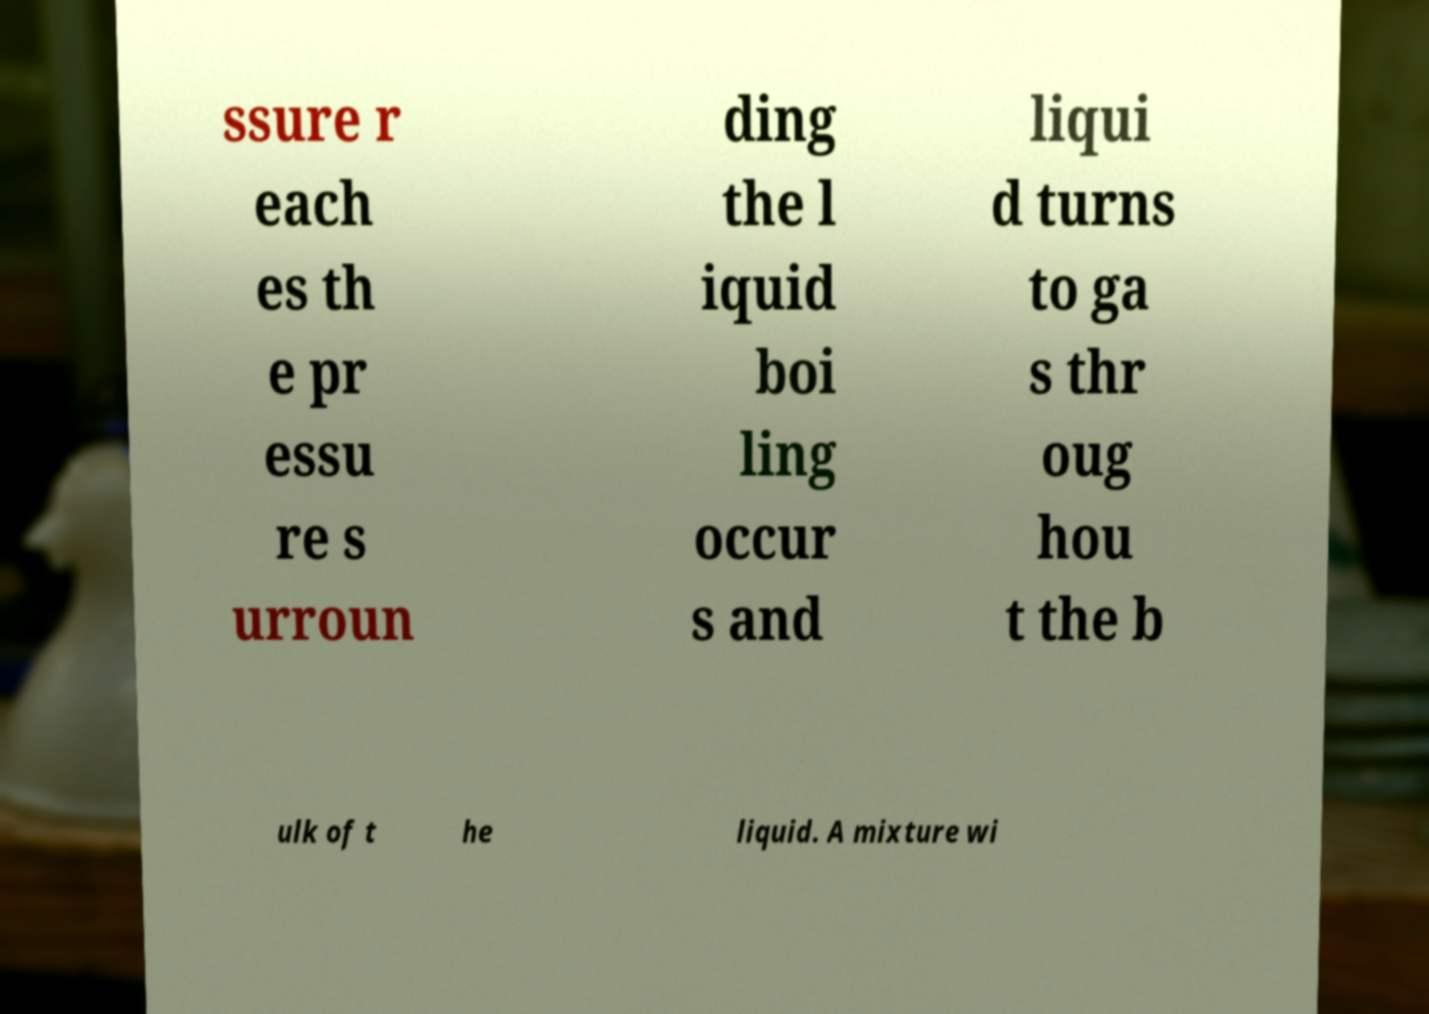Could you assist in decoding the text presented in this image and type it out clearly? ssure r each es th e pr essu re s urroun ding the l iquid boi ling occur s and liqui d turns to ga s thr oug hou t the b ulk of t he liquid. A mixture wi 